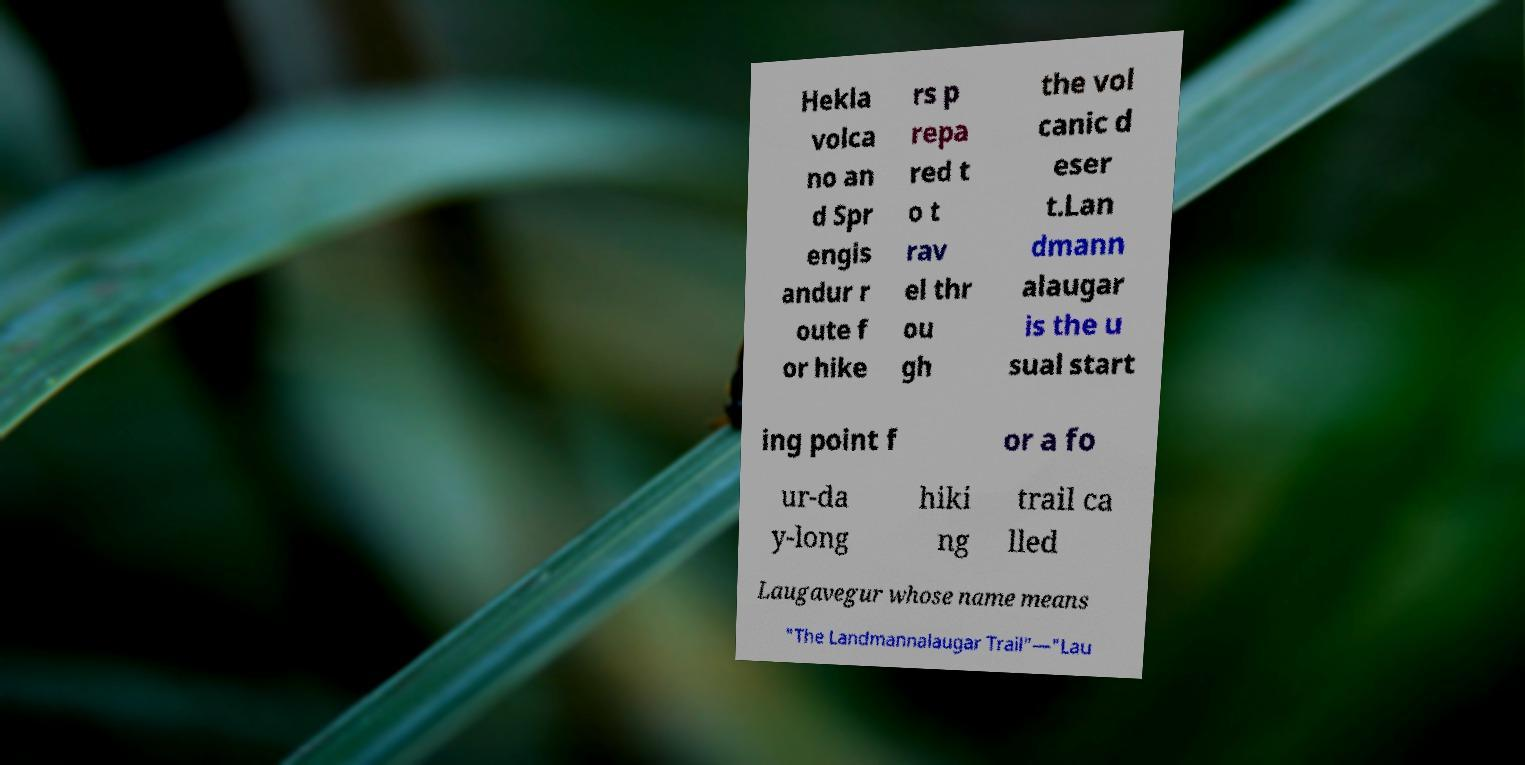There's text embedded in this image that I need extracted. Can you transcribe it verbatim? Hekla volca no an d Spr engis andur r oute f or hike rs p repa red t o t rav el thr ou gh the vol canic d eser t.Lan dmann alaugar is the u sual start ing point f or a fo ur-da y-long hiki ng trail ca lled Laugavegur whose name means "The Landmannalaugar Trail"—"Lau 